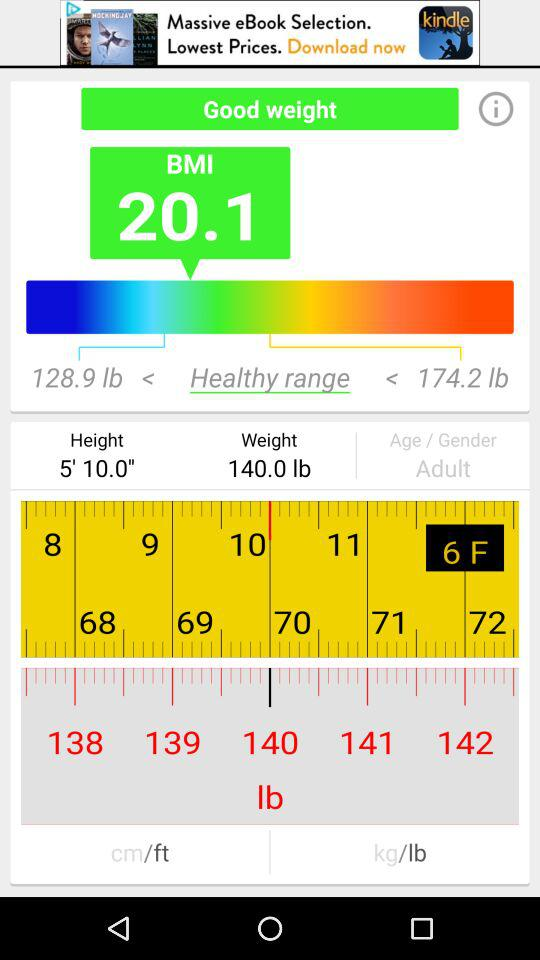What is the current weight range?
Answer the question using a single word or phrase. 128.9 lb - 174.2 lb 